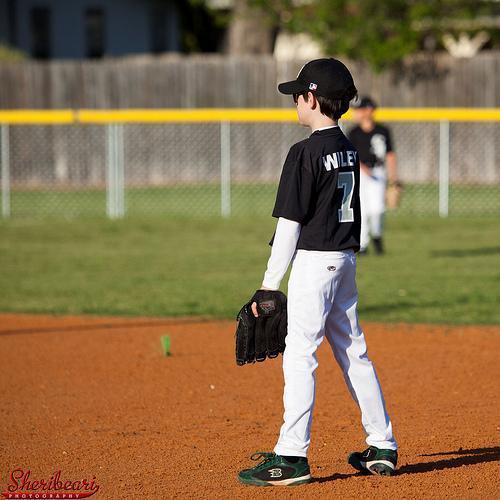How many players are on the field?
Give a very brief answer. 2. 